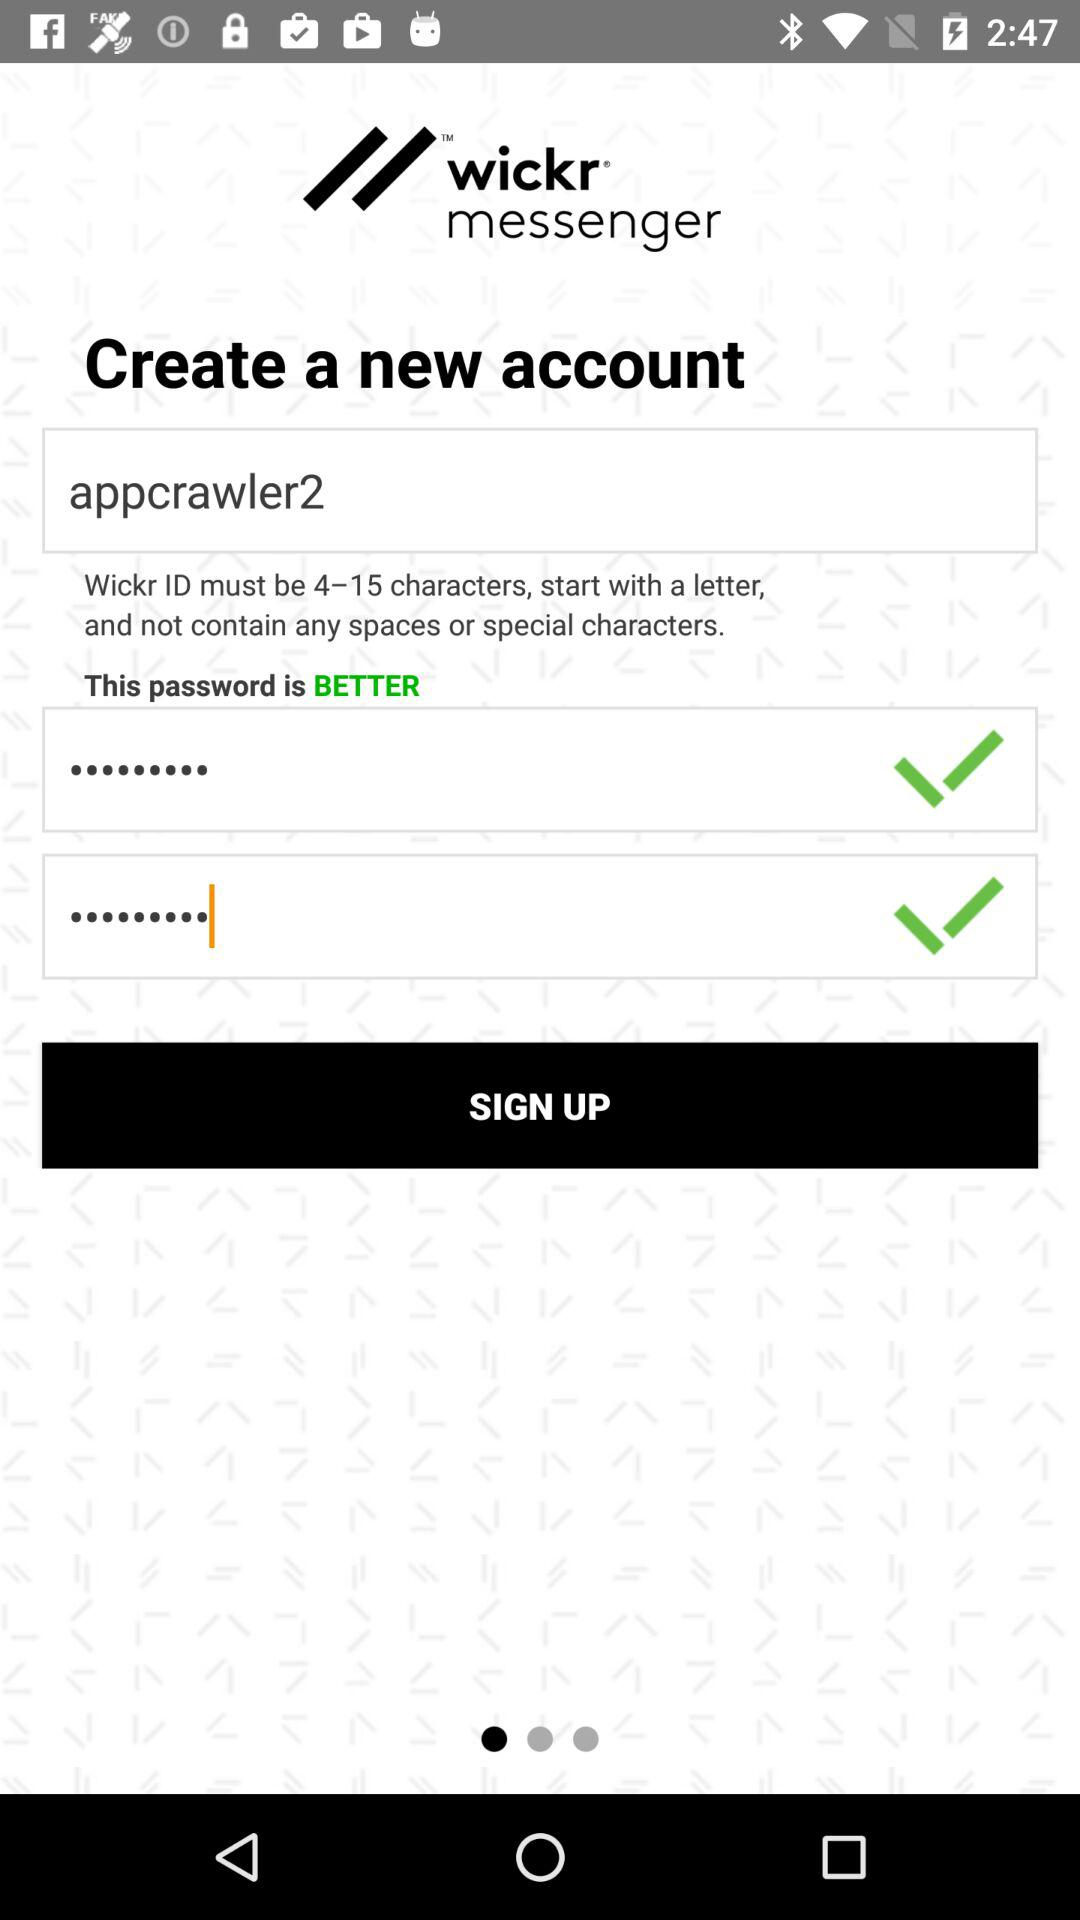How many text inputs have a checkmark next to them?
Answer the question using a single word or phrase. 2 